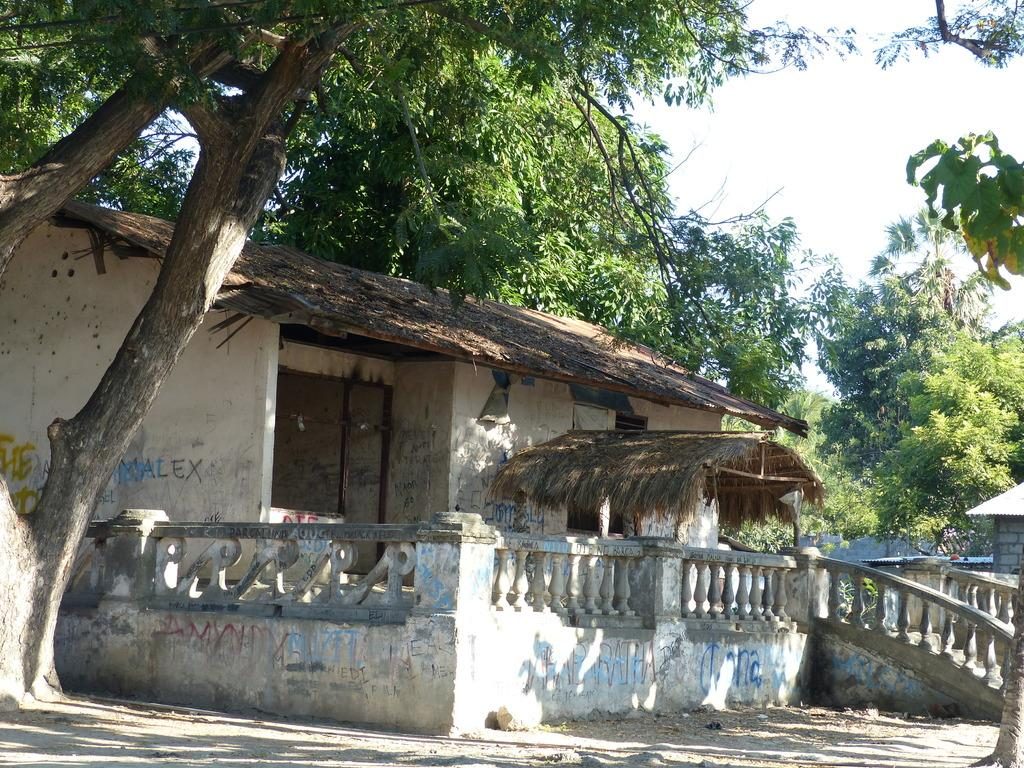What type of structure is present in the image? There is a house in the image. What are the main features of the house? The house has a roof, walls, and a railing. What can be seen in the surroundings of the house? There are many trees in the image. What is visible in the background of the image? There is a sky visible in the background of the image. What type of nerve is present in the image? There is no nerve present in the image; it features a house with a roof, walls, and a railing, surrounded by trees and a visible sky. 